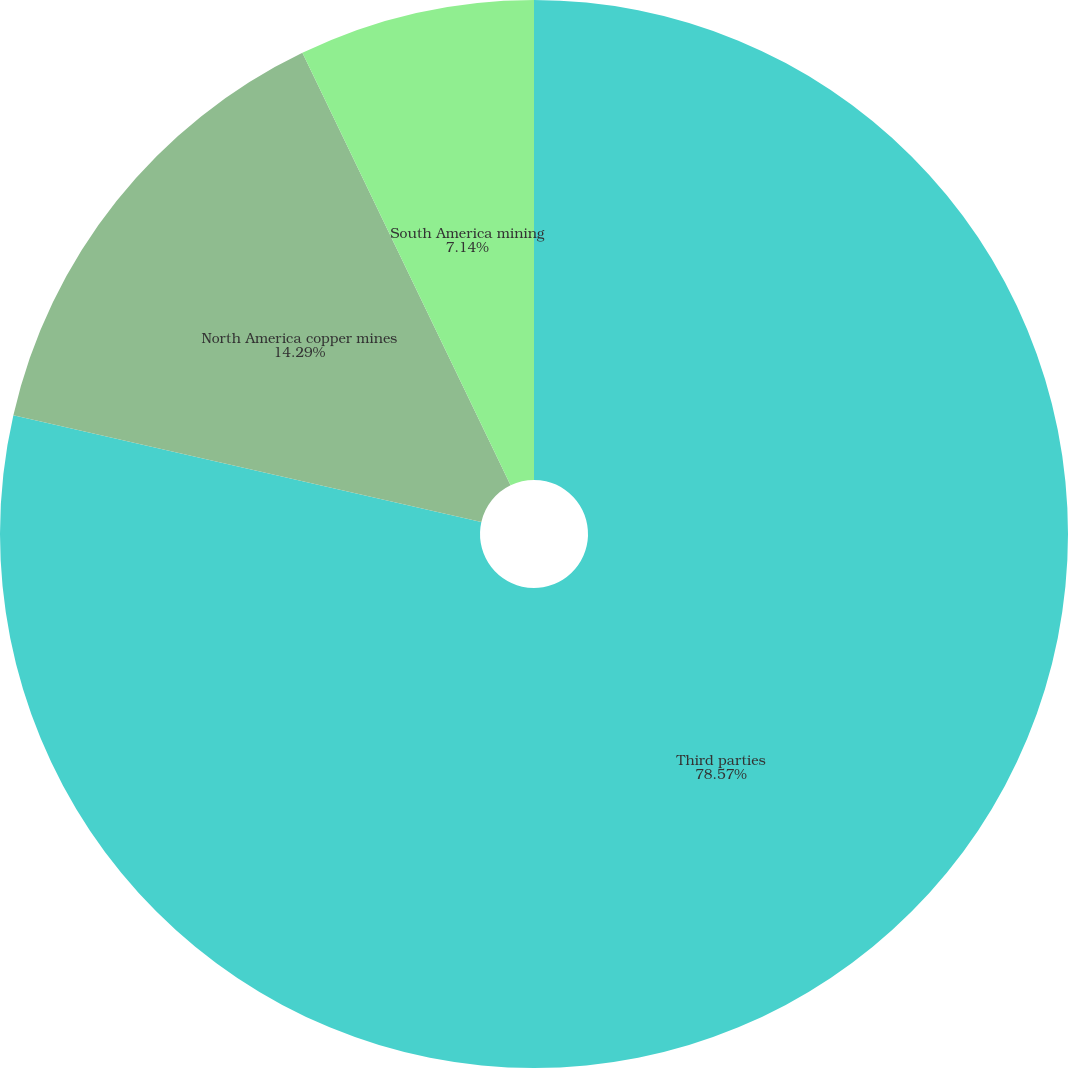<chart> <loc_0><loc_0><loc_500><loc_500><pie_chart><fcel>Third parties<fcel>North America copper mines<fcel>South America mining<nl><fcel>78.57%<fcel>14.29%<fcel>7.14%<nl></chart> 